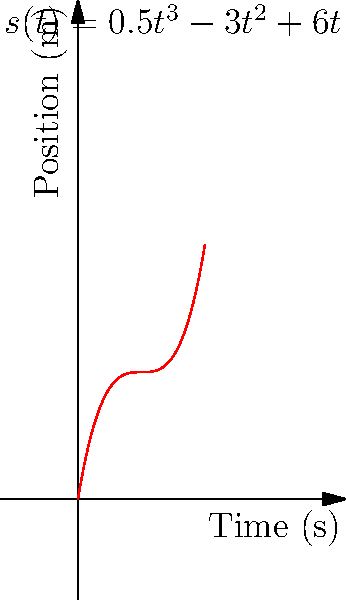Given the position-time graph of a piston's motion described by the function $s(t) = 0.5t^3 - 3t^2 + 6t$, where $s$ is in meters and $t$ is in seconds, determine the piston's acceleration at $t = 2$ seconds. How does this acceleration compare to the typical acceleration experienced during a timing belt failure? To find the acceleration at $t = 2$ seconds, we need to follow these steps:

1) The velocity function $v(t)$ is the first derivative of the position function:
   $$v(t) = \frac{d}{dt}[s(t)] = \frac{d}{dt}[0.5t^3 - 3t^2 + 6t] = 1.5t^2 - 6t + 6$$

2) The acceleration function $a(t)$ is the second derivative of the position function, or the first derivative of the velocity function:
   $$a(t) = \frac{d}{dt}[v(t)] = \frac{d}{dt}[1.5t^2 - 6t + 6] = 3t - 6$$

3) To find the acceleration at $t = 2$ seconds, we substitute $t = 2$ into $a(t)$:
   $$a(2) = 3(2) - 6 = 6 - 6 = 0 \text{ m/s}^2$$

4) The acceleration at $t = 2$ seconds is 0 m/s^2, meaning the piston is neither speeding up nor slowing down at this instant.

5) Comparing to a timing belt failure: During a timing belt failure, a piston can experience extreme accelerations due to mistimed valve openings or collisions with valves. These accelerations can easily exceed 1000 m/s^2 or more, potentially causing catastrophic engine damage.

The zero acceleration at $t = 2$ in this controlled motion is significantly less than the extreme accelerations experienced during a timing belt failure, highlighting the importance of proper timing belt maintenance to prevent such dangerous situations.
Answer: 0 m/s^2; significantly less than accelerations during timing belt failure 